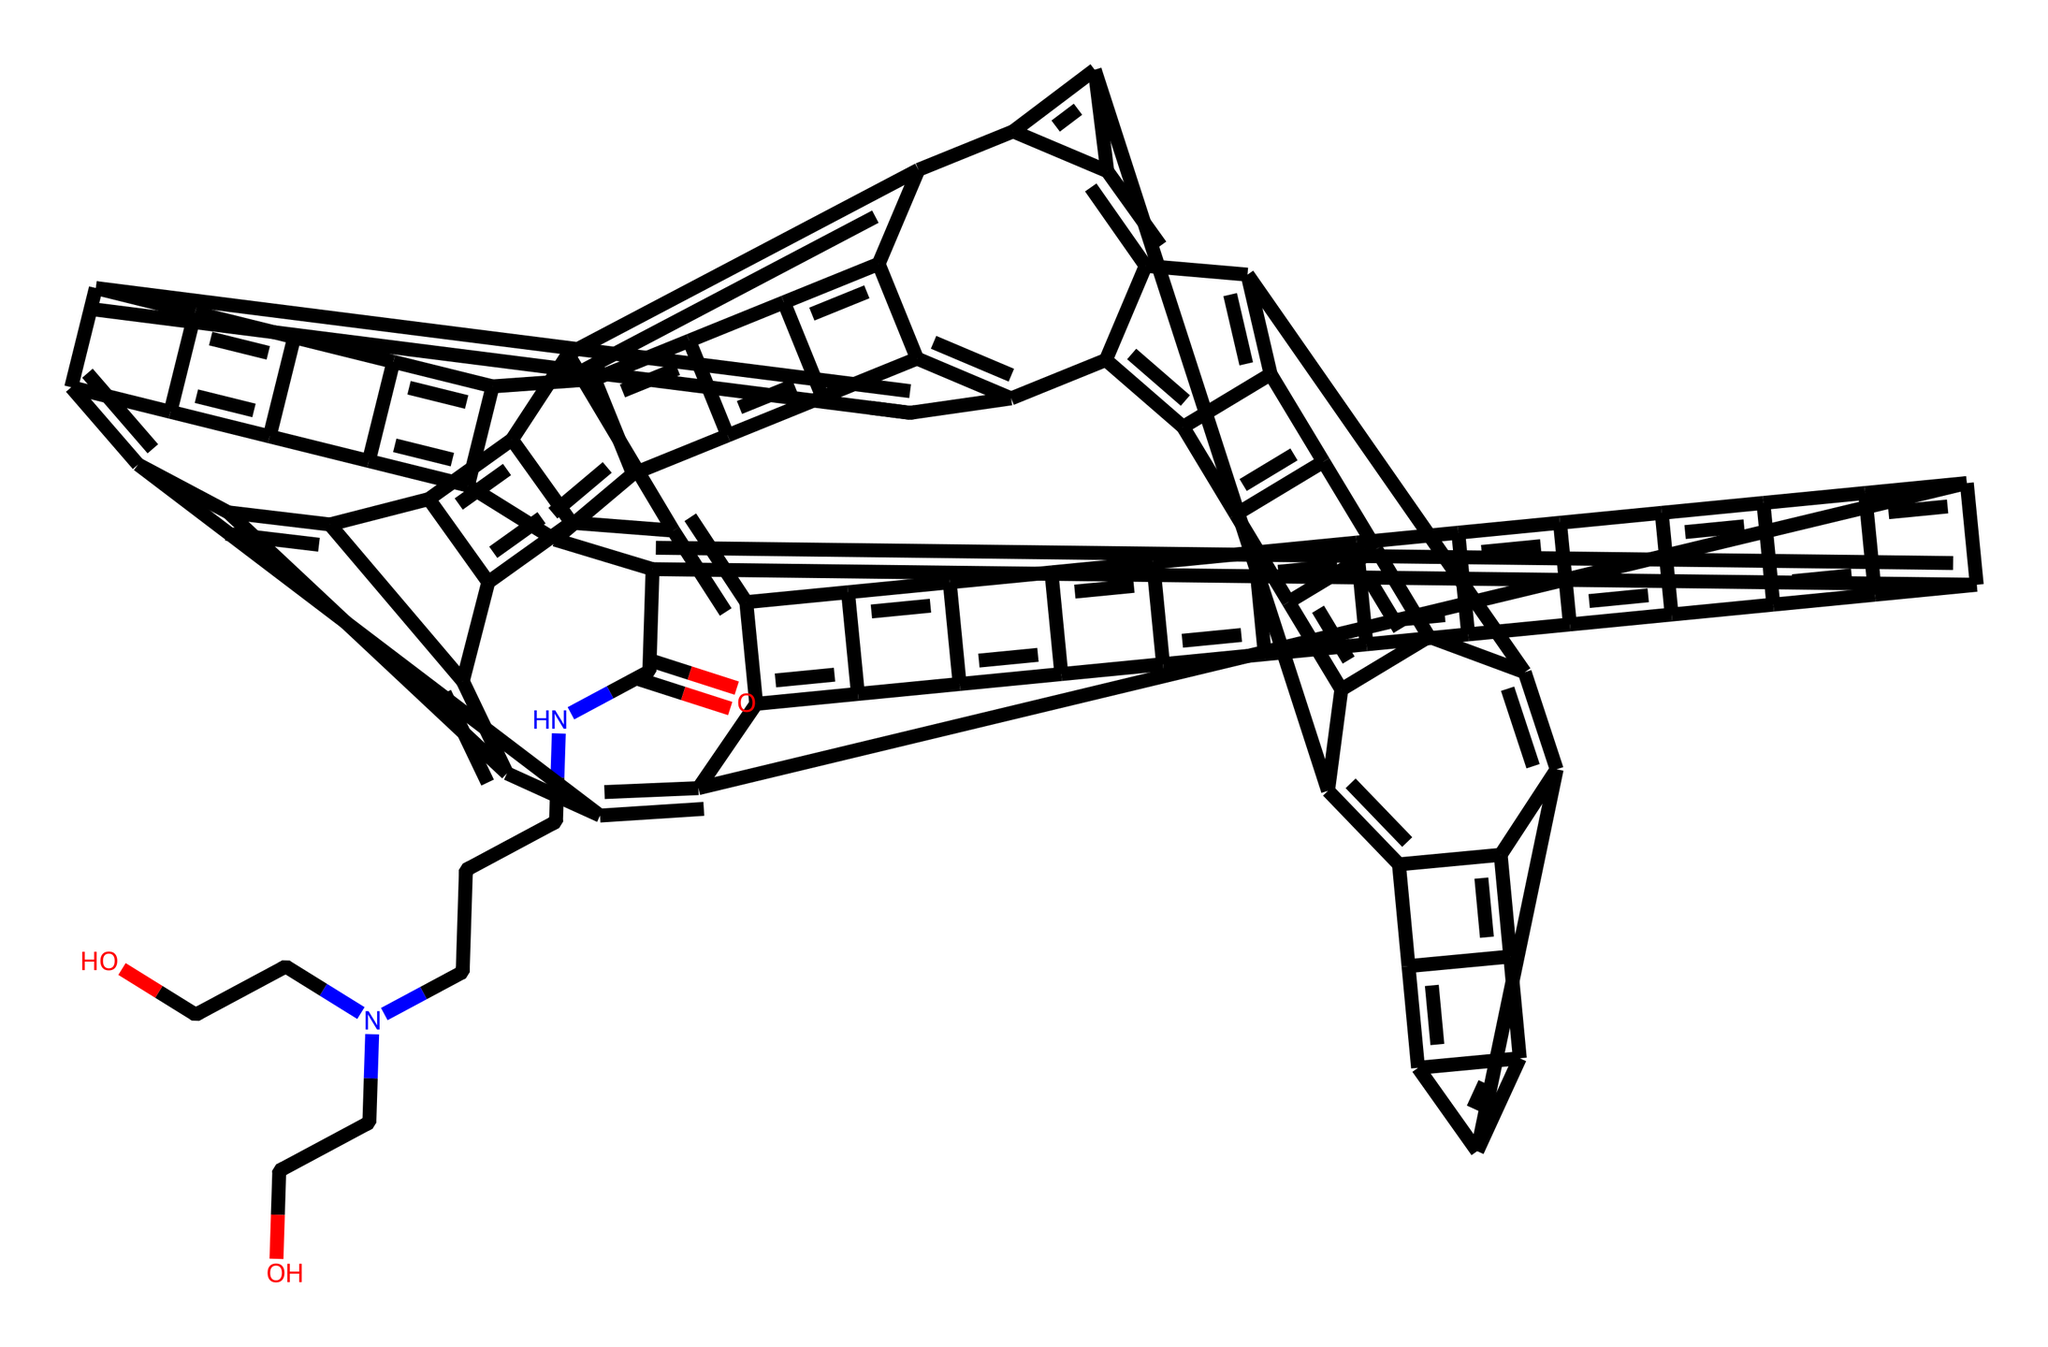What is the molecular formula of this compound? The SMILES representation indicates the type and number of atoms in the compound, particularly the main elements present. By analyzing the structure, we can tally the counts of carbon (C), hydrogen (H), nitrogen (N), and oxygen (O). The main component here is found to include a significant number of carbon atoms along with some nitrogen and oxygen, leading to the specifications of the molecular formula.
Answer: C66H90N4O4 How many carbon atoms are in this fullerene derivative? Counting the number of "C" present in the SMILES string, we can determine the total number of carbon atoms in the compound. The string provides a detailed breakdown revealing this derivative has a total of sixty-six carbon atoms.
Answer: 66 What functional groups are present in this chemical? Analyzing the structure reveals identifiable functional groups by looking for specific bonds. In this case, the presence of "N" indicates an amine group, while "O" signifies a carbonyl (ketone) and hydroxyl groups (from "CCO" fragments). Recognizing these patterns helps identify the functional groups.
Answer: amine, carbonyl, hydroxyl What is the degree of saturation in this fullerene? The degree of saturation can be determined by evaluating the number of rings and double bonds within the structure. In fullerene derivatives like this, multiple cyclic structures and double bonds contribute to high saturation levels. A detailed analysis shows a significant number of such features suggesting a high degree of saturation.
Answer: high Does this chemical structure suggest high solubility in water? The presence of polar functional groups such as hydroxyl groups (from the "CCO" fragments) and amine groups contributes to its solubility in water. These polar functional groups can interact with water, suggesting that the compound can indeed be soluble.
Answer: yes Where is the amino group located in the structure? To identify the position of the amino group, we examine the SMILES for the "N" symbol, which indicates an amino group. The adjacent carbon fragments relay the spatial arrangement in the structure, leading to the conclusion that the amino group is part of the chain.
Answer: in the side chain What can we infer about the cellular uptake potential of this fullerene derivative? The presence of multiple functional groups (hydroxyl and amine) enhances the hydrophilicity of the compound, which is crucial for cellular uptake. Based on its water-solubility and structure, one can infer higher potential for cellular interaction and uptake due to enhanced compatibility with biological environments.
Answer: high potential 